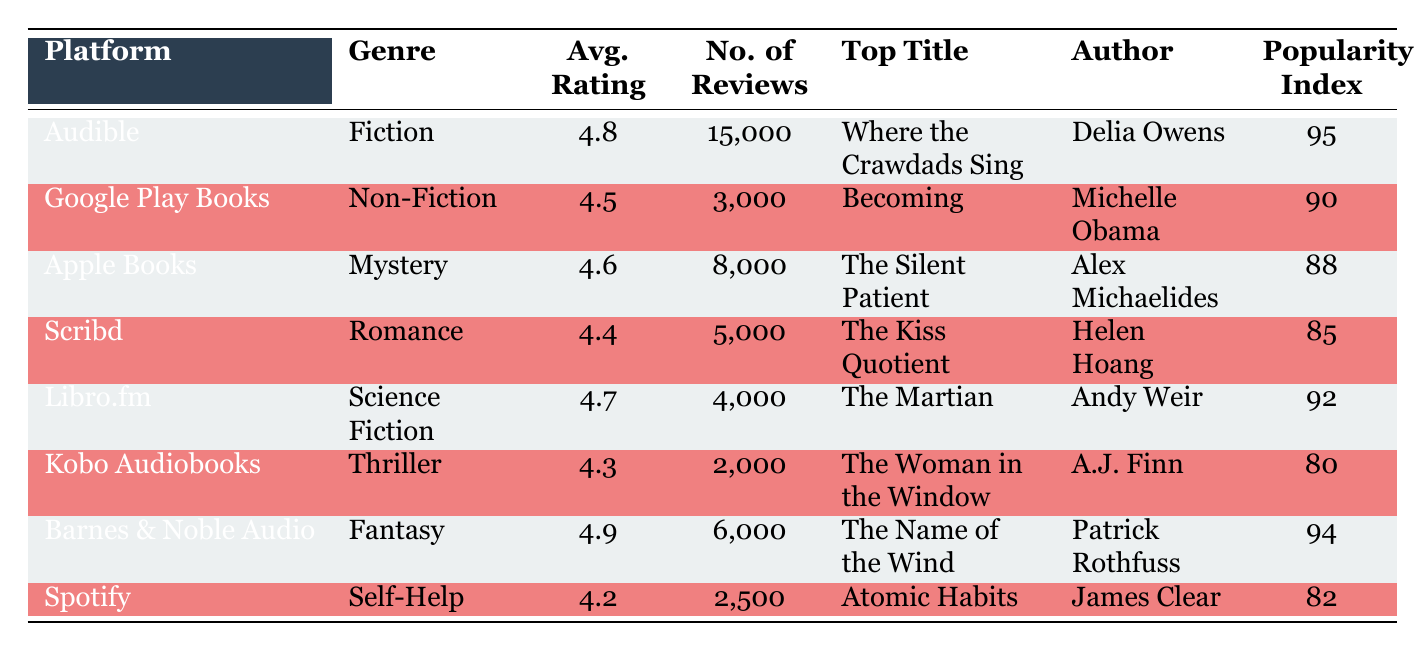What is the average rating for audiobooks on Audible? The average rating for Audible is listed in the table under the "Avg. Rating" column. It shows an average rating of 4.8.
Answer: 4.8 Which platform has the highest popularity index? By comparing the "Popularity Index" values across all platforms, Audible has the highest index at 95.
Answer: Audible What is the difference in the number of reviews between Google Play Books and Barnes & Noble Audio? For Google Play Books, the number of reviews is 3000, while for Barnes & Noble Audio, it is 6000. The difference is 6000 - 3000 = 3000.
Answer: 3000 Are there more reviews for The Martian or Atomic Habits? The Martian has 4000 reviews, while Atomic Habits has 2500 reviews. Since 4000 is greater than 2500, there are more reviews for The Martian.
Answer: Yes What is the average rating of the audiobooks listed in the table? The average can be calculated by first summing the ratings: (4.8 + 4.5 + 4.6 + 4.4 + 4.7 + 4.3 + 4.9 + 4.2) = 36.4 and then dividing by the number of platforms (8). The average rating is 36.4 / 8 = 4.55.
Answer: 4.55 Which genre appears to be most popular based on the average rating? By reviewing the average ratings for each genre in the table, Fiction and Fantasy stand out with average ratings of 4.8 and 4.9 respectively. Fantasy has the highest rating, suggesting it being the most popular genre.
Answer: Fantasy Is the average rating for self-help audiobooks above the average rating of all audiobooks? The self-help genre (Spotify) has an average rating of 4.2, while the overall average rating calculated earlier is 4.55. Comparing the two shows that 4.2 is below 4.55.
Answer: No Which author has written the top title in the genre of Romance? The top title in the Romance genre is "The Kiss Quotient," and it is authored by Helen Hoang as stated in the table.
Answer: Helen Hoang 